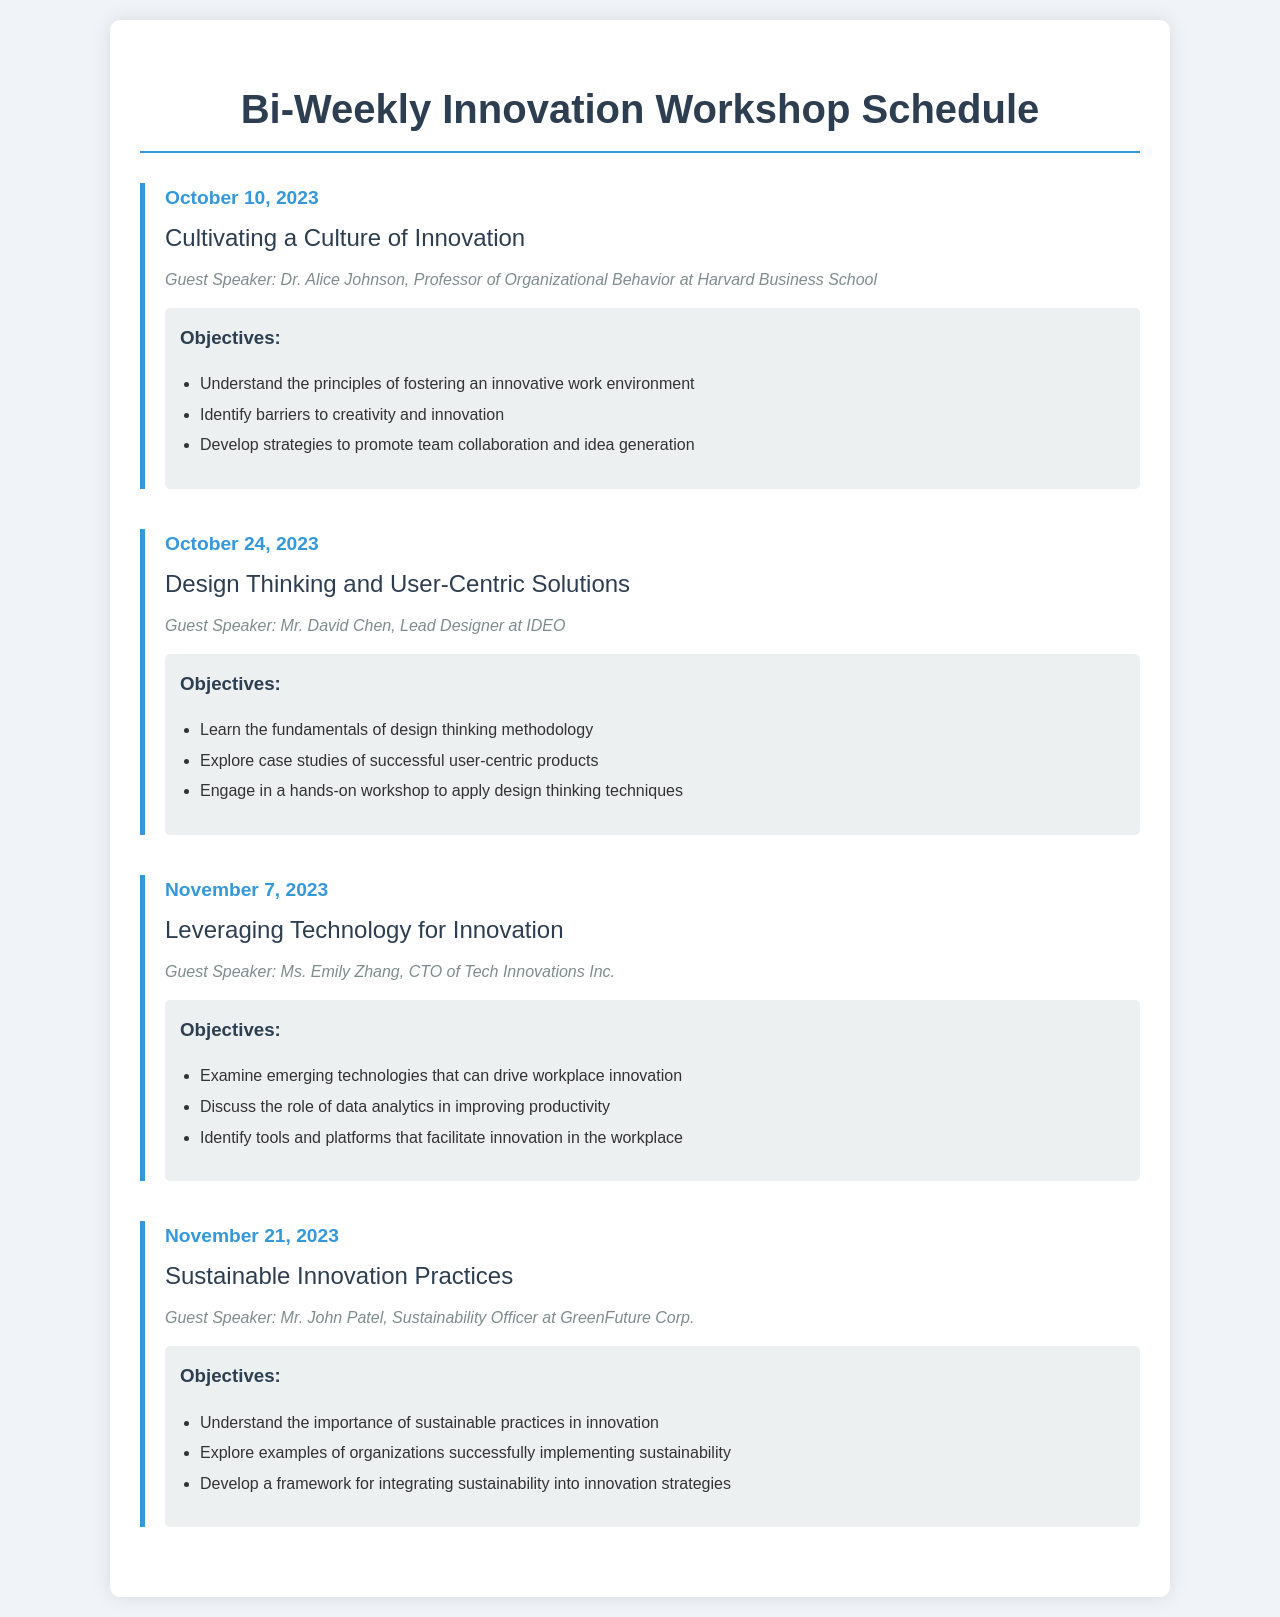What is the date of the first workshop? The first workshop is scheduled for October 10, 2023, as mentioned in the document.
Answer: October 10, 2023 Who is the guest speaker for the workshop on November 7, 2023? The guest speaker for the workshop on November 7, 2023 is Ms. Emily Zhang, as indicated in the schedule.
Answer: Ms. Emily Zhang What is one of the objectives of the workshop on October 24, 2023? One objective stated for the workshop on October 24, 2023 is to "Learn the fundamentals of design thinking methodology."
Answer: Learn the fundamentals of design thinking methodology How many workshops are scheduled in total? The document outlines a total of four workshops.
Answer: Four What topic will be discussed on November 21, 2023? The topic scheduled for November 21, 2023 is "Sustainable Innovation Practices."
Answer: Sustainable Innovation Practices Name one emerging technology discussed in the workshop on November 7, 2023. The document does not specify any technologies but mentions examining "emerging technologies that can drive workplace innovation."
Answer: Emerging technologies What is the main focus of the workshop on October 10, 2023? The main focus of the October 10, 2023 workshop is "Cultivating a Culture of Innovation."
Answer: Cultivating a Culture of Innovation What is the main theme of the workshop on October 24, 2023? The main theme of the workshop on October 24, 2023 is "Design Thinking and User-Centric Solutions."
Answer: Design Thinking and User-Centric Solutions 